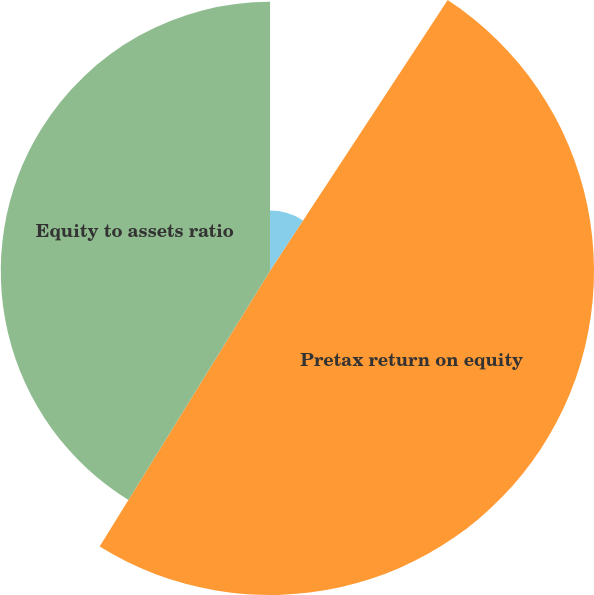Convert chart. <chart><loc_0><loc_0><loc_500><loc_500><pie_chart><fcel>Pretax return on assets<fcel>Pretax return on equity<fcel>Equity to assets ratio<nl><fcel>9.24%<fcel>49.57%<fcel>41.19%<nl></chart> 